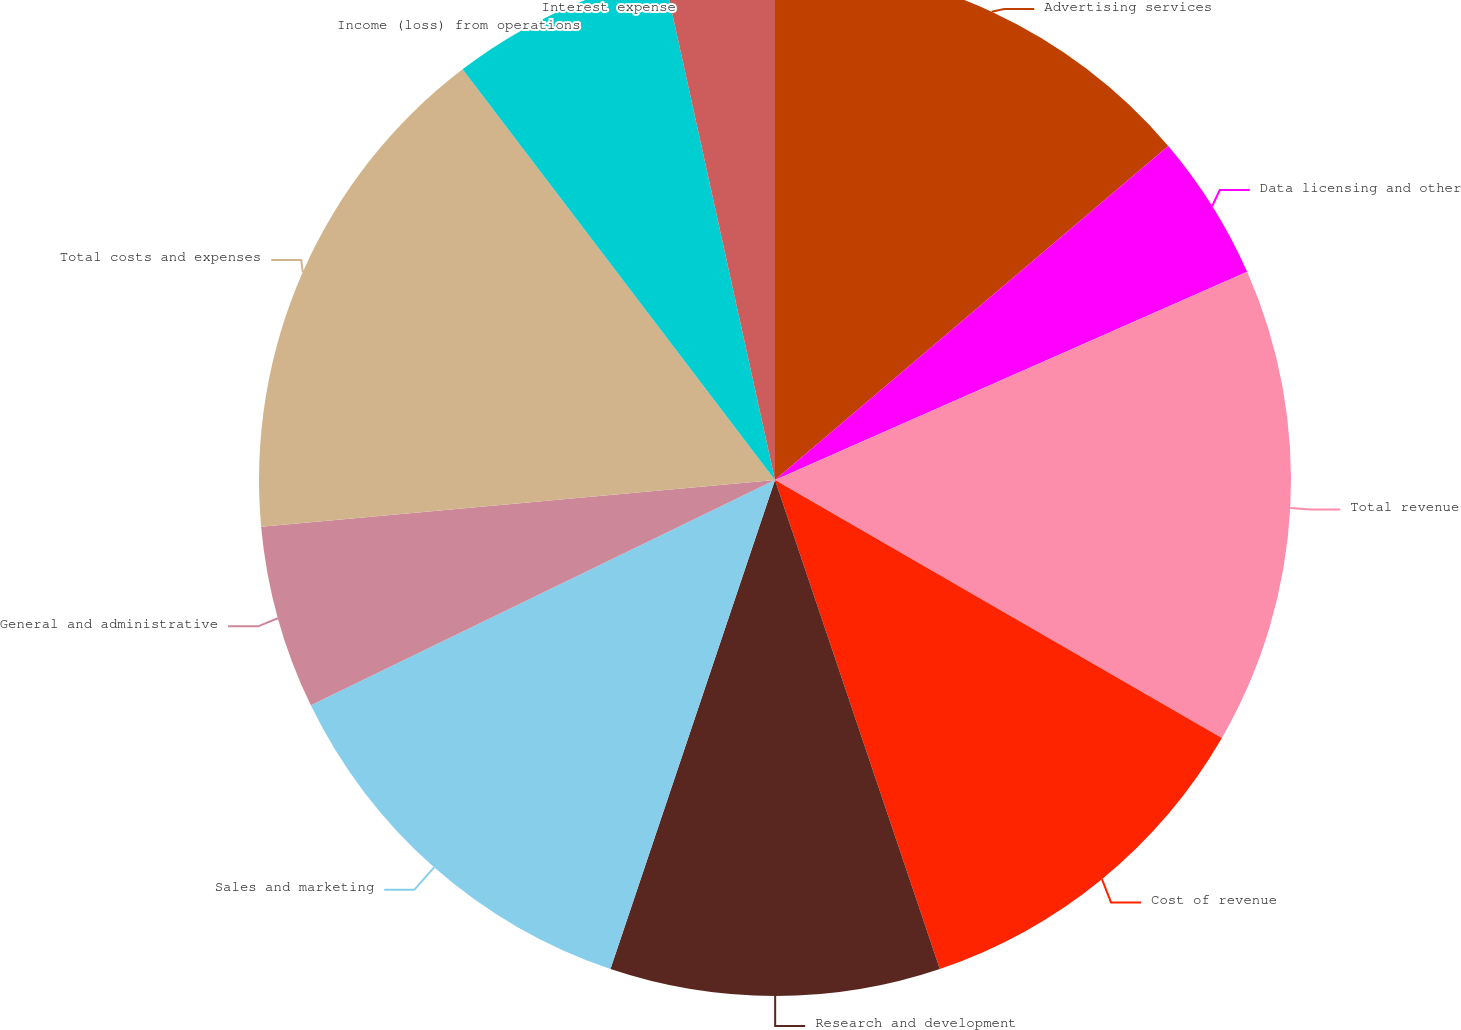Convert chart to OTSL. <chart><loc_0><loc_0><loc_500><loc_500><pie_chart><fcel>Advertising services<fcel>Data licensing and other<fcel>Total revenue<fcel>Cost of revenue<fcel>Research and development<fcel>Sales and marketing<fcel>General and administrative<fcel>Total costs and expenses<fcel>Income (loss) from operations<fcel>Interest expense<nl><fcel>13.79%<fcel>4.6%<fcel>14.94%<fcel>11.49%<fcel>10.34%<fcel>12.64%<fcel>5.75%<fcel>16.09%<fcel>6.9%<fcel>3.45%<nl></chart> 